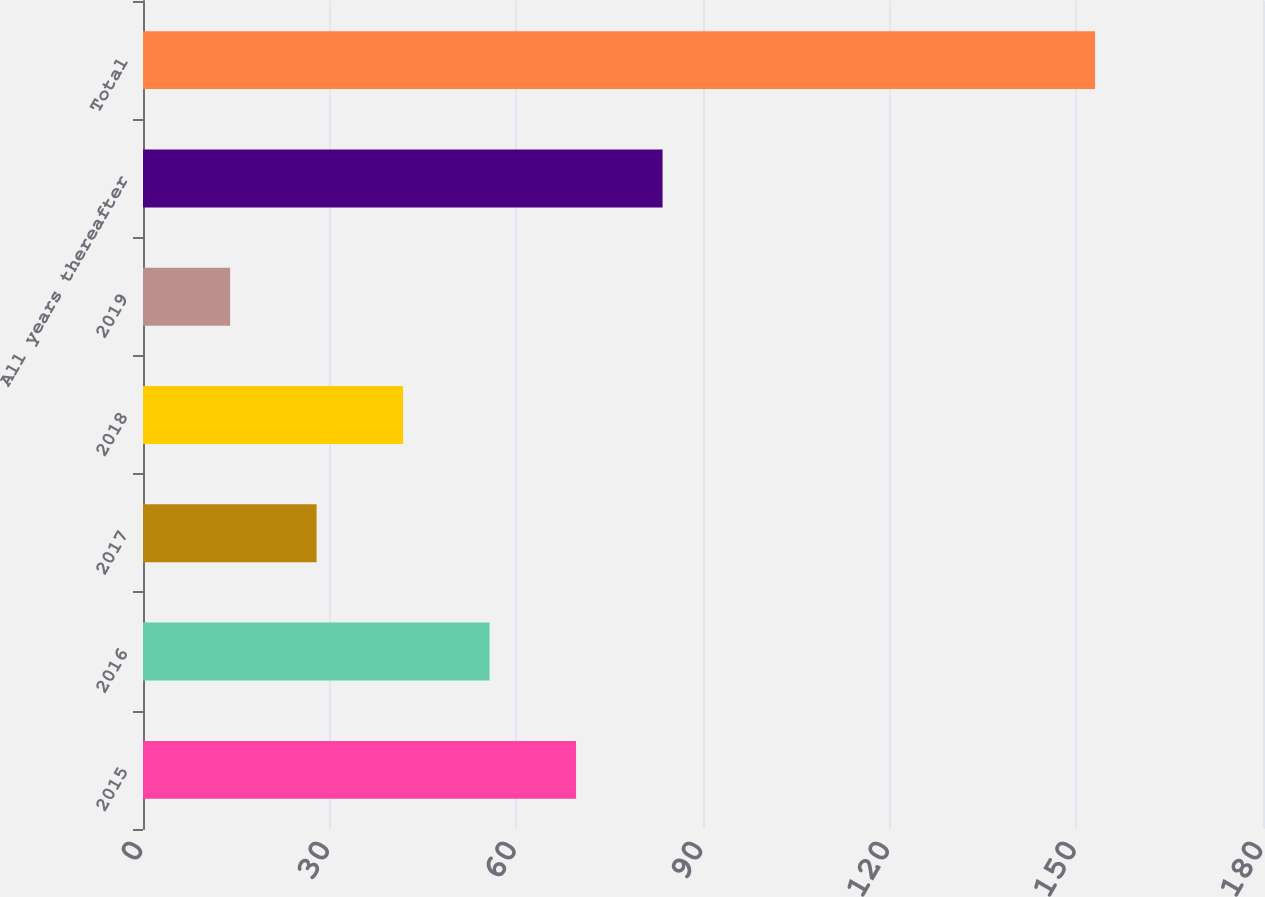Convert chart. <chart><loc_0><loc_0><loc_500><loc_500><bar_chart><fcel>2015<fcel>2016<fcel>2017<fcel>2018<fcel>2019<fcel>All years thereafter<fcel>Total<nl><fcel>69.6<fcel>55.7<fcel>27.9<fcel>41.8<fcel>14<fcel>83.5<fcel>153<nl></chart> 